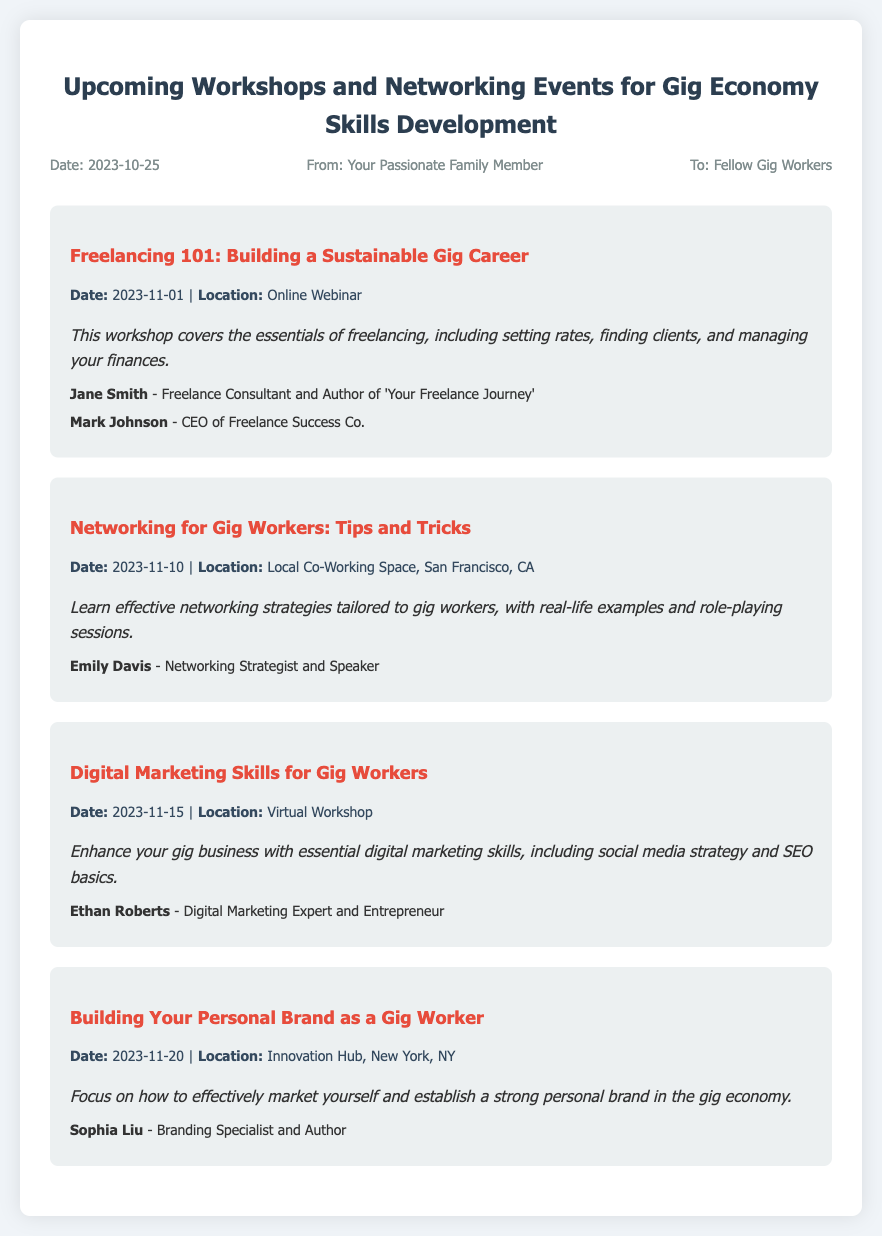What is the date of the first workshop? The first workshop titled "Freelancing 101: Building a Sustainable Gig Career" is scheduled for November 1, 2023.
Answer: November 1, 2023 Where is the networking event taking place? The networking event titled "Networking for Gig Workers: Tips and Tricks" will be held at a Local Co-Working Space in San Francisco, CA.
Answer: Local Co-Working Space, San Francisco, CA Who is speaking at the digital marketing workshop? The digital marketing workshop features Ethan Roberts as the speaker.
Answer: Ethan Roberts What is the location of the workshop on personal branding? The workshop titled "Building Your Personal Brand as a Gig Worker" will take place at the Innovation Hub in New York, NY.
Answer: Innovation Hub, New York, NY How many events are listed in the memo? The memo includes a total of four upcoming workshops and networking events.
Answer: Four 